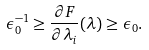<formula> <loc_0><loc_0><loc_500><loc_500>\epsilon _ { 0 } ^ { - 1 } \geq \frac { \partial F } { \partial \lambda _ { i } } ( \lambda ) \geq \epsilon _ { 0 } .</formula> 